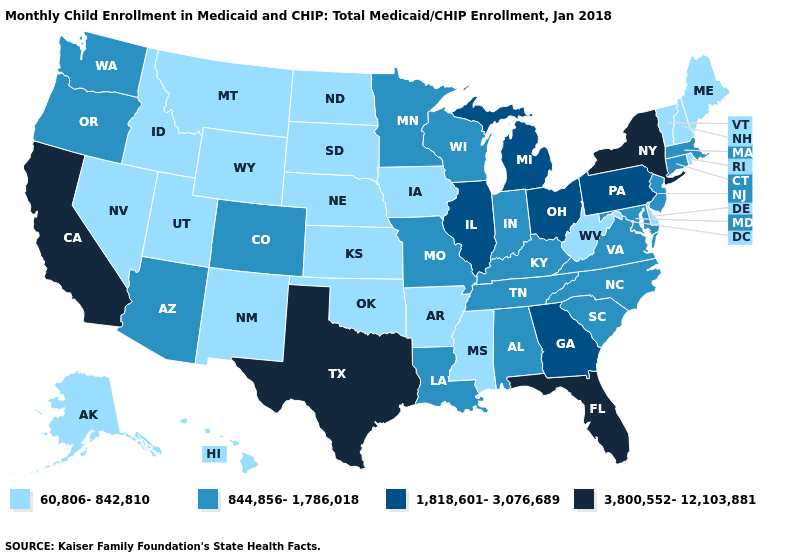Does Illinois have the same value as Tennessee?
Write a very short answer. No. Name the states that have a value in the range 1,818,601-3,076,689?
Keep it brief. Georgia, Illinois, Michigan, Ohio, Pennsylvania. Which states have the lowest value in the USA?
Keep it brief. Alaska, Arkansas, Delaware, Hawaii, Idaho, Iowa, Kansas, Maine, Mississippi, Montana, Nebraska, Nevada, New Hampshire, New Mexico, North Dakota, Oklahoma, Rhode Island, South Dakota, Utah, Vermont, West Virginia, Wyoming. What is the value of Alaska?
Quick response, please. 60,806-842,810. Does the first symbol in the legend represent the smallest category?
Be succinct. Yes. What is the value of Pennsylvania?
Answer briefly. 1,818,601-3,076,689. What is the value of Wyoming?
Short answer required. 60,806-842,810. What is the value of South Carolina?
Be succinct. 844,856-1,786,018. Name the states that have a value in the range 1,818,601-3,076,689?
Short answer required. Georgia, Illinois, Michigan, Ohio, Pennsylvania. Name the states that have a value in the range 60,806-842,810?
Write a very short answer. Alaska, Arkansas, Delaware, Hawaii, Idaho, Iowa, Kansas, Maine, Mississippi, Montana, Nebraska, Nevada, New Hampshire, New Mexico, North Dakota, Oklahoma, Rhode Island, South Dakota, Utah, Vermont, West Virginia, Wyoming. Name the states that have a value in the range 60,806-842,810?
Be succinct. Alaska, Arkansas, Delaware, Hawaii, Idaho, Iowa, Kansas, Maine, Mississippi, Montana, Nebraska, Nevada, New Hampshire, New Mexico, North Dakota, Oklahoma, Rhode Island, South Dakota, Utah, Vermont, West Virginia, Wyoming. What is the lowest value in the MidWest?
Write a very short answer. 60,806-842,810. Name the states that have a value in the range 3,800,552-12,103,881?
Short answer required. California, Florida, New York, Texas. Name the states that have a value in the range 60,806-842,810?
Answer briefly. Alaska, Arkansas, Delaware, Hawaii, Idaho, Iowa, Kansas, Maine, Mississippi, Montana, Nebraska, Nevada, New Hampshire, New Mexico, North Dakota, Oklahoma, Rhode Island, South Dakota, Utah, Vermont, West Virginia, Wyoming. Name the states that have a value in the range 844,856-1,786,018?
Give a very brief answer. Alabama, Arizona, Colorado, Connecticut, Indiana, Kentucky, Louisiana, Maryland, Massachusetts, Minnesota, Missouri, New Jersey, North Carolina, Oregon, South Carolina, Tennessee, Virginia, Washington, Wisconsin. 